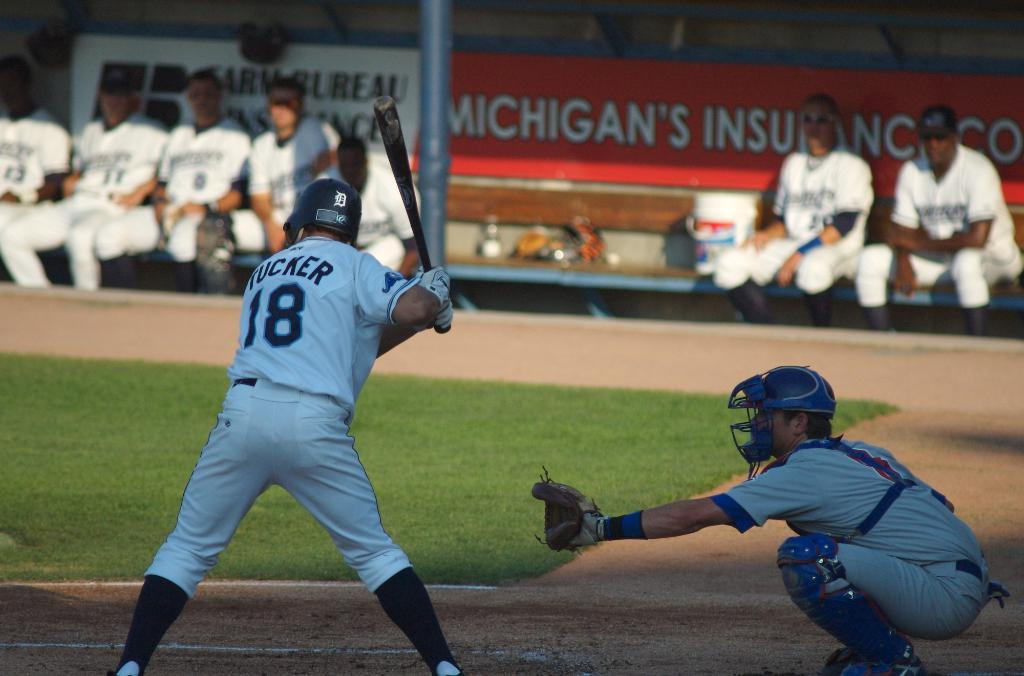<image>
Create a compact narrative representing the image presented. Number 18 batter holding his bat with umpire in back. 